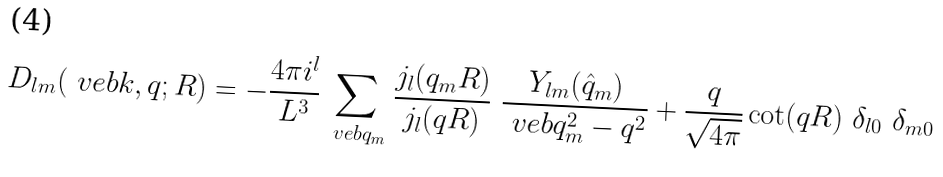Convert formula to latex. <formula><loc_0><loc_0><loc_500><loc_500>D _ { l m } ( \ v e b { k } , q ; R ) = - \frac { 4 \pi i ^ { l } } { L ^ { 3 } } \sum _ { \ v e b { q } _ { m } } { \frac { j _ { l } ( q _ { m } R ) } { j _ { l } ( q R ) } \ \frac { Y _ { l m } ( \hat { q } _ { m } ) } { \ v e b { q } _ { m } ^ { 2 } - q ^ { 2 } } } + \frac { q } { \sqrt { 4 \pi } } \cot ( q R ) \ \delta _ { l 0 } \ \delta _ { m 0 }</formula> 